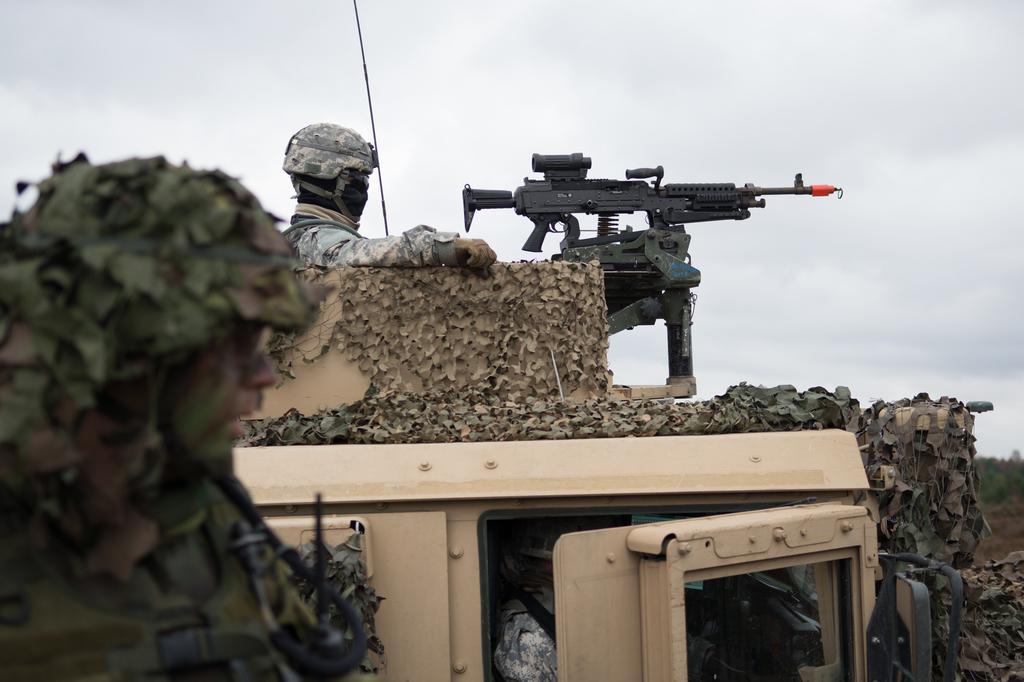In one or two sentences, can you explain what this image depicts? In this image we can see two people and a gun in a vehicle, some trees and the sky which looks cloudy. In the foreground we can see a person wearing a helmet. 